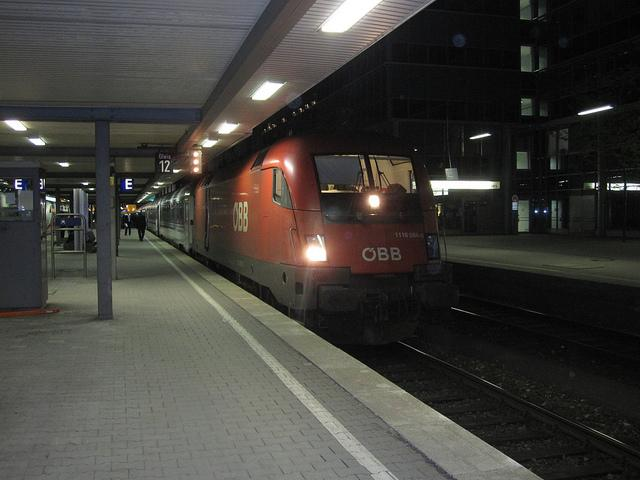What letter appears twice in a row on the train?

Choices:
A) g
B) d
C) w
D) b b 